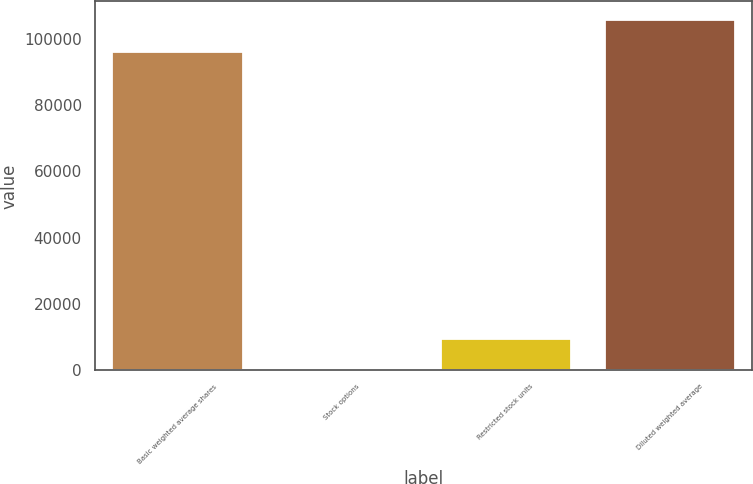Convert chart. <chart><loc_0><loc_0><loc_500><loc_500><bar_chart><fcel>Basic weighted average shares<fcel>Stock options<fcel>Restricted stock units<fcel>Diluted weighted average<nl><fcel>96309<fcel>31<fcel>9689.9<fcel>105968<nl></chart> 